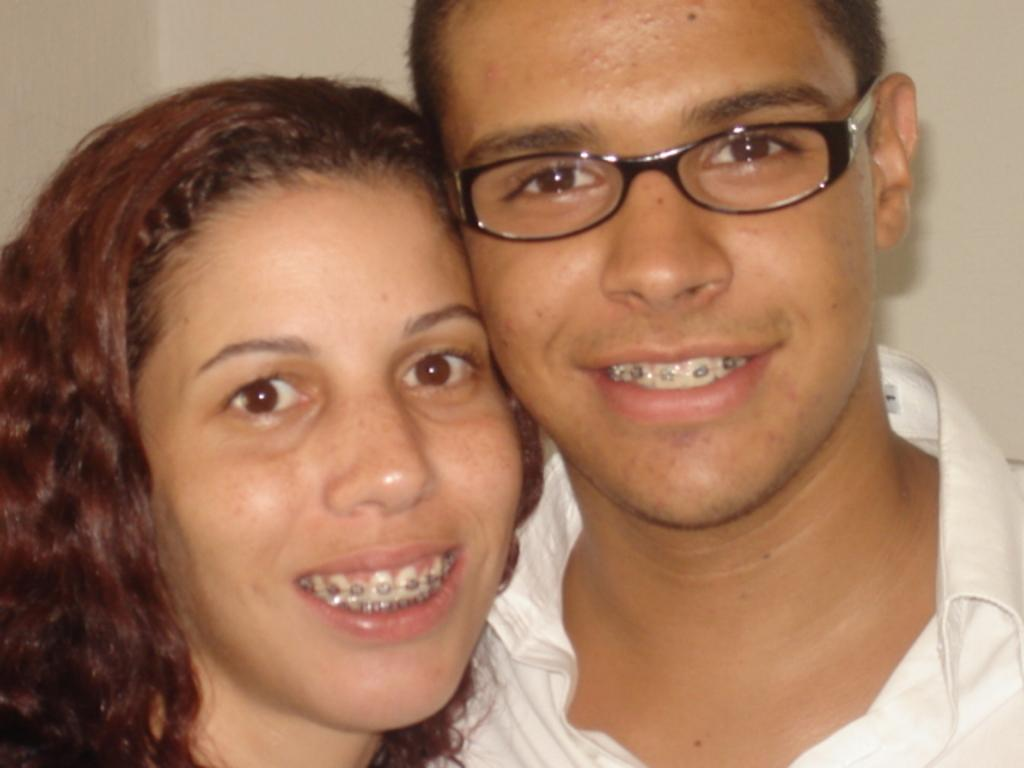Who is present in the image? There is a man and a woman in the image. What is the man wearing? The man is wearing a white shirt. What can be seen in the background of the image? There is a wall in the background of the image. What type of division is taking place in the image? There is no division or separation of any kind depicted in the image. What instrument is the man playing in the image? There is no instrument present in the image, and the man is not playing any musical instrument. 